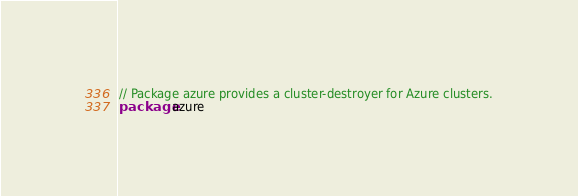Convert code to text. <code><loc_0><loc_0><loc_500><loc_500><_Go_>// Package azure provides a cluster-destroyer for Azure clusters.
package azure
</code> 